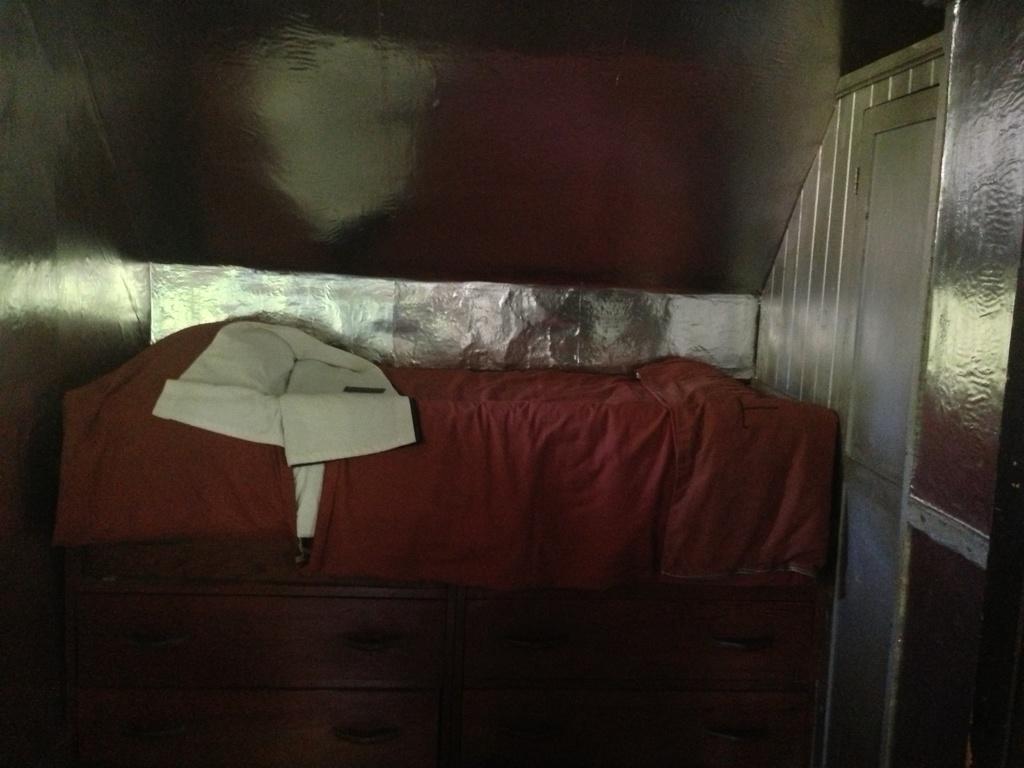Can you describe this image briefly? In the picture I can see a bed which has a red color blanket on it. On the right side I can see a door. 